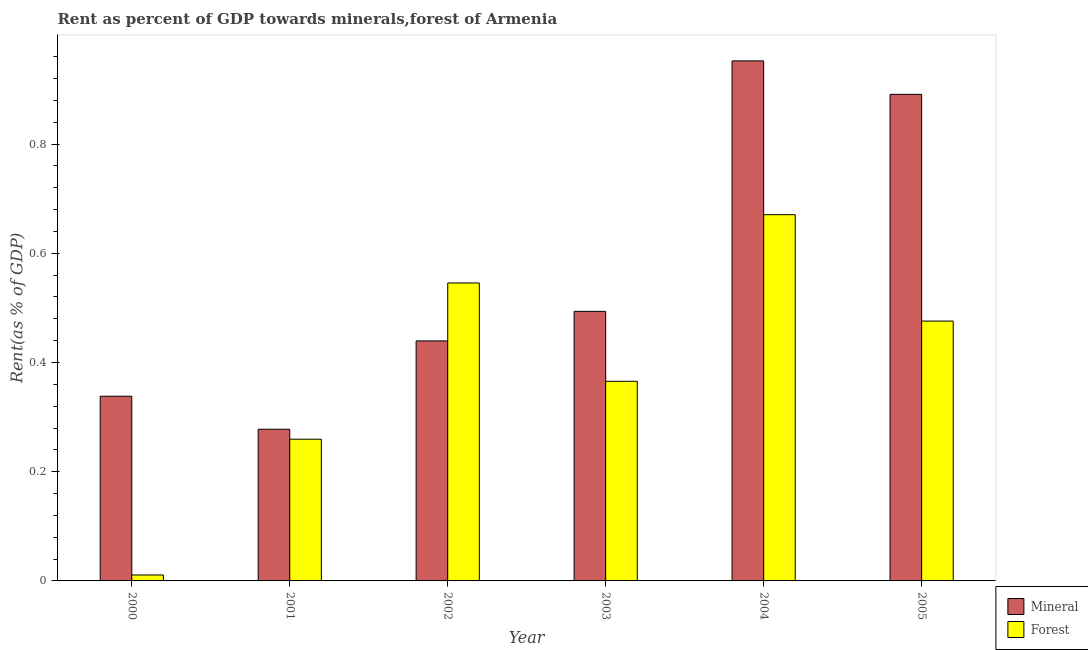How many different coloured bars are there?
Offer a terse response. 2. How many groups of bars are there?
Your response must be concise. 6. Are the number of bars per tick equal to the number of legend labels?
Offer a terse response. Yes. Are the number of bars on each tick of the X-axis equal?
Your answer should be compact. Yes. What is the label of the 6th group of bars from the left?
Your answer should be compact. 2005. In how many cases, is the number of bars for a given year not equal to the number of legend labels?
Your answer should be compact. 0. What is the forest rent in 2003?
Ensure brevity in your answer.  0.37. Across all years, what is the maximum mineral rent?
Keep it short and to the point. 0.95. Across all years, what is the minimum forest rent?
Offer a very short reply. 0.01. What is the total forest rent in the graph?
Keep it short and to the point. 2.33. What is the difference between the mineral rent in 2003 and that in 2004?
Give a very brief answer. -0.46. What is the difference between the mineral rent in 2004 and the forest rent in 2002?
Keep it short and to the point. 0.51. What is the average forest rent per year?
Your answer should be compact. 0.39. In the year 2003, what is the difference between the forest rent and mineral rent?
Provide a short and direct response. 0. In how many years, is the forest rent greater than 0.7200000000000001 %?
Give a very brief answer. 0. What is the ratio of the forest rent in 2000 to that in 2002?
Provide a short and direct response. 0.02. Is the mineral rent in 2000 less than that in 2004?
Give a very brief answer. Yes. Is the difference between the mineral rent in 2000 and 2002 greater than the difference between the forest rent in 2000 and 2002?
Your response must be concise. No. What is the difference between the highest and the second highest mineral rent?
Offer a terse response. 0.06. What is the difference between the highest and the lowest forest rent?
Provide a succinct answer. 0.66. In how many years, is the forest rent greater than the average forest rent taken over all years?
Provide a short and direct response. 3. What does the 2nd bar from the left in 2000 represents?
Keep it short and to the point. Forest. What does the 2nd bar from the right in 2000 represents?
Make the answer very short. Mineral. Are all the bars in the graph horizontal?
Your response must be concise. No. What is the difference between two consecutive major ticks on the Y-axis?
Give a very brief answer. 0.2. Does the graph contain grids?
Make the answer very short. No. Where does the legend appear in the graph?
Provide a short and direct response. Bottom right. How many legend labels are there?
Offer a very short reply. 2. How are the legend labels stacked?
Give a very brief answer. Vertical. What is the title of the graph?
Offer a very short reply. Rent as percent of GDP towards minerals,forest of Armenia. What is the label or title of the X-axis?
Offer a terse response. Year. What is the label or title of the Y-axis?
Your response must be concise. Rent(as % of GDP). What is the Rent(as % of GDP) of Mineral in 2000?
Give a very brief answer. 0.34. What is the Rent(as % of GDP) in Forest in 2000?
Your answer should be compact. 0.01. What is the Rent(as % of GDP) in Mineral in 2001?
Give a very brief answer. 0.28. What is the Rent(as % of GDP) of Forest in 2001?
Give a very brief answer. 0.26. What is the Rent(as % of GDP) in Mineral in 2002?
Offer a terse response. 0.44. What is the Rent(as % of GDP) of Forest in 2002?
Ensure brevity in your answer.  0.55. What is the Rent(as % of GDP) of Mineral in 2003?
Your response must be concise. 0.49. What is the Rent(as % of GDP) of Forest in 2003?
Provide a succinct answer. 0.37. What is the Rent(as % of GDP) in Mineral in 2004?
Provide a short and direct response. 0.95. What is the Rent(as % of GDP) in Forest in 2004?
Your answer should be very brief. 0.67. What is the Rent(as % of GDP) in Mineral in 2005?
Give a very brief answer. 0.89. What is the Rent(as % of GDP) in Forest in 2005?
Your answer should be very brief. 0.48. Across all years, what is the maximum Rent(as % of GDP) of Mineral?
Your answer should be very brief. 0.95. Across all years, what is the maximum Rent(as % of GDP) of Forest?
Your response must be concise. 0.67. Across all years, what is the minimum Rent(as % of GDP) of Mineral?
Ensure brevity in your answer.  0.28. Across all years, what is the minimum Rent(as % of GDP) of Forest?
Give a very brief answer. 0.01. What is the total Rent(as % of GDP) of Mineral in the graph?
Your response must be concise. 3.39. What is the total Rent(as % of GDP) of Forest in the graph?
Your response must be concise. 2.33. What is the difference between the Rent(as % of GDP) of Mineral in 2000 and that in 2001?
Make the answer very short. 0.06. What is the difference between the Rent(as % of GDP) in Forest in 2000 and that in 2001?
Your response must be concise. -0.25. What is the difference between the Rent(as % of GDP) in Mineral in 2000 and that in 2002?
Provide a short and direct response. -0.1. What is the difference between the Rent(as % of GDP) in Forest in 2000 and that in 2002?
Your response must be concise. -0.53. What is the difference between the Rent(as % of GDP) in Mineral in 2000 and that in 2003?
Provide a short and direct response. -0.16. What is the difference between the Rent(as % of GDP) in Forest in 2000 and that in 2003?
Your answer should be compact. -0.35. What is the difference between the Rent(as % of GDP) of Mineral in 2000 and that in 2004?
Make the answer very short. -0.61. What is the difference between the Rent(as % of GDP) of Forest in 2000 and that in 2004?
Provide a succinct answer. -0.66. What is the difference between the Rent(as % of GDP) in Mineral in 2000 and that in 2005?
Offer a terse response. -0.55. What is the difference between the Rent(as % of GDP) of Forest in 2000 and that in 2005?
Your answer should be very brief. -0.47. What is the difference between the Rent(as % of GDP) of Mineral in 2001 and that in 2002?
Offer a terse response. -0.16. What is the difference between the Rent(as % of GDP) in Forest in 2001 and that in 2002?
Offer a terse response. -0.29. What is the difference between the Rent(as % of GDP) of Mineral in 2001 and that in 2003?
Provide a succinct answer. -0.22. What is the difference between the Rent(as % of GDP) in Forest in 2001 and that in 2003?
Provide a short and direct response. -0.11. What is the difference between the Rent(as % of GDP) in Mineral in 2001 and that in 2004?
Your answer should be very brief. -0.67. What is the difference between the Rent(as % of GDP) in Forest in 2001 and that in 2004?
Your answer should be very brief. -0.41. What is the difference between the Rent(as % of GDP) of Mineral in 2001 and that in 2005?
Your answer should be very brief. -0.61. What is the difference between the Rent(as % of GDP) in Forest in 2001 and that in 2005?
Your response must be concise. -0.22. What is the difference between the Rent(as % of GDP) of Mineral in 2002 and that in 2003?
Provide a succinct answer. -0.05. What is the difference between the Rent(as % of GDP) in Forest in 2002 and that in 2003?
Your response must be concise. 0.18. What is the difference between the Rent(as % of GDP) in Mineral in 2002 and that in 2004?
Ensure brevity in your answer.  -0.51. What is the difference between the Rent(as % of GDP) of Forest in 2002 and that in 2004?
Keep it short and to the point. -0.12. What is the difference between the Rent(as % of GDP) of Mineral in 2002 and that in 2005?
Give a very brief answer. -0.45. What is the difference between the Rent(as % of GDP) of Forest in 2002 and that in 2005?
Give a very brief answer. 0.07. What is the difference between the Rent(as % of GDP) in Mineral in 2003 and that in 2004?
Your answer should be compact. -0.46. What is the difference between the Rent(as % of GDP) in Forest in 2003 and that in 2004?
Give a very brief answer. -0.31. What is the difference between the Rent(as % of GDP) in Mineral in 2003 and that in 2005?
Ensure brevity in your answer.  -0.4. What is the difference between the Rent(as % of GDP) in Forest in 2003 and that in 2005?
Keep it short and to the point. -0.11. What is the difference between the Rent(as % of GDP) in Mineral in 2004 and that in 2005?
Provide a short and direct response. 0.06. What is the difference between the Rent(as % of GDP) of Forest in 2004 and that in 2005?
Ensure brevity in your answer.  0.19. What is the difference between the Rent(as % of GDP) in Mineral in 2000 and the Rent(as % of GDP) in Forest in 2001?
Offer a terse response. 0.08. What is the difference between the Rent(as % of GDP) of Mineral in 2000 and the Rent(as % of GDP) of Forest in 2002?
Ensure brevity in your answer.  -0.21. What is the difference between the Rent(as % of GDP) of Mineral in 2000 and the Rent(as % of GDP) of Forest in 2003?
Ensure brevity in your answer.  -0.03. What is the difference between the Rent(as % of GDP) of Mineral in 2000 and the Rent(as % of GDP) of Forest in 2004?
Provide a succinct answer. -0.33. What is the difference between the Rent(as % of GDP) of Mineral in 2000 and the Rent(as % of GDP) of Forest in 2005?
Keep it short and to the point. -0.14. What is the difference between the Rent(as % of GDP) in Mineral in 2001 and the Rent(as % of GDP) in Forest in 2002?
Your answer should be very brief. -0.27. What is the difference between the Rent(as % of GDP) in Mineral in 2001 and the Rent(as % of GDP) in Forest in 2003?
Make the answer very short. -0.09. What is the difference between the Rent(as % of GDP) of Mineral in 2001 and the Rent(as % of GDP) of Forest in 2004?
Keep it short and to the point. -0.39. What is the difference between the Rent(as % of GDP) of Mineral in 2001 and the Rent(as % of GDP) of Forest in 2005?
Give a very brief answer. -0.2. What is the difference between the Rent(as % of GDP) in Mineral in 2002 and the Rent(as % of GDP) in Forest in 2003?
Provide a short and direct response. 0.07. What is the difference between the Rent(as % of GDP) of Mineral in 2002 and the Rent(as % of GDP) of Forest in 2004?
Give a very brief answer. -0.23. What is the difference between the Rent(as % of GDP) in Mineral in 2002 and the Rent(as % of GDP) in Forest in 2005?
Ensure brevity in your answer.  -0.04. What is the difference between the Rent(as % of GDP) in Mineral in 2003 and the Rent(as % of GDP) in Forest in 2004?
Your response must be concise. -0.18. What is the difference between the Rent(as % of GDP) in Mineral in 2003 and the Rent(as % of GDP) in Forest in 2005?
Make the answer very short. 0.02. What is the difference between the Rent(as % of GDP) in Mineral in 2004 and the Rent(as % of GDP) in Forest in 2005?
Ensure brevity in your answer.  0.48. What is the average Rent(as % of GDP) in Mineral per year?
Ensure brevity in your answer.  0.57. What is the average Rent(as % of GDP) in Forest per year?
Offer a very short reply. 0.39. In the year 2000, what is the difference between the Rent(as % of GDP) in Mineral and Rent(as % of GDP) in Forest?
Ensure brevity in your answer.  0.33. In the year 2001, what is the difference between the Rent(as % of GDP) of Mineral and Rent(as % of GDP) of Forest?
Offer a very short reply. 0.02. In the year 2002, what is the difference between the Rent(as % of GDP) in Mineral and Rent(as % of GDP) in Forest?
Keep it short and to the point. -0.11. In the year 2003, what is the difference between the Rent(as % of GDP) in Mineral and Rent(as % of GDP) in Forest?
Provide a short and direct response. 0.13. In the year 2004, what is the difference between the Rent(as % of GDP) of Mineral and Rent(as % of GDP) of Forest?
Provide a short and direct response. 0.28. In the year 2005, what is the difference between the Rent(as % of GDP) of Mineral and Rent(as % of GDP) of Forest?
Provide a short and direct response. 0.42. What is the ratio of the Rent(as % of GDP) of Mineral in 2000 to that in 2001?
Offer a terse response. 1.22. What is the ratio of the Rent(as % of GDP) in Forest in 2000 to that in 2001?
Keep it short and to the point. 0.04. What is the ratio of the Rent(as % of GDP) in Mineral in 2000 to that in 2002?
Provide a succinct answer. 0.77. What is the ratio of the Rent(as % of GDP) of Forest in 2000 to that in 2002?
Provide a succinct answer. 0.02. What is the ratio of the Rent(as % of GDP) of Mineral in 2000 to that in 2003?
Offer a terse response. 0.69. What is the ratio of the Rent(as % of GDP) of Forest in 2000 to that in 2003?
Ensure brevity in your answer.  0.03. What is the ratio of the Rent(as % of GDP) in Mineral in 2000 to that in 2004?
Offer a terse response. 0.36. What is the ratio of the Rent(as % of GDP) in Forest in 2000 to that in 2004?
Provide a succinct answer. 0.02. What is the ratio of the Rent(as % of GDP) of Mineral in 2000 to that in 2005?
Keep it short and to the point. 0.38. What is the ratio of the Rent(as % of GDP) in Forest in 2000 to that in 2005?
Make the answer very short. 0.02. What is the ratio of the Rent(as % of GDP) in Mineral in 2001 to that in 2002?
Make the answer very short. 0.63. What is the ratio of the Rent(as % of GDP) in Forest in 2001 to that in 2002?
Your answer should be compact. 0.48. What is the ratio of the Rent(as % of GDP) of Mineral in 2001 to that in 2003?
Give a very brief answer. 0.56. What is the ratio of the Rent(as % of GDP) in Forest in 2001 to that in 2003?
Offer a terse response. 0.71. What is the ratio of the Rent(as % of GDP) of Mineral in 2001 to that in 2004?
Offer a very short reply. 0.29. What is the ratio of the Rent(as % of GDP) of Forest in 2001 to that in 2004?
Your answer should be compact. 0.39. What is the ratio of the Rent(as % of GDP) in Mineral in 2001 to that in 2005?
Give a very brief answer. 0.31. What is the ratio of the Rent(as % of GDP) in Forest in 2001 to that in 2005?
Ensure brevity in your answer.  0.55. What is the ratio of the Rent(as % of GDP) of Mineral in 2002 to that in 2003?
Give a very brief answer. 0.89. What is the ratio of the Rent(as % of GDP) in Forest in 2002 to that in 2003?
Your answer should be very brief. 1.49. What is the ratio of the Rent(as % of GDP) in Mineral in 2002 to that in 2004?
Your response must be concise. 0.46. What is the ratio of the Rent(as % of GDP) in Forest in 2002 to that in 2004?
Your answer should be very brief. 0.81. What is the ratio of the Rent(as % of GDP) of Mineral in 2002 to that in 2005?
Your response must be concise. 0.49. What is the ratio of the Rent(as % of GDP) in Forest in 2002 to that in 2005?
Keep it short and to the point. 1.15. What is the ratio of the Rent(as % of GDP) in Mineral in 2003 to that in 2004?
Offer a terse response. 0.52. What is the ratio of the Rent(as % of GDP) of Forest in 2003 to that in 2004?
Your answer should be very brief. 0.55. What is the ratio of the Rent(as % of GDP) in Mineral in 2003 to that in 2005?
Offer a terse response. 0.55. What is the ratio of the Rent(as % of GDP) in Forest in 2003 to that in 2005?
Your answer should be compact. 0.77. What is the ratio of the Rent(as % of GDP) in Mineral in 2004 to that in 2005?
Your response must be concise. 1.07. What is the ratio of the Rent(as % of GDP) of Forest in 2004 to that in 2005?
Provide a succinct answer. 1.41. What is the difference between the highest and the second highest Rent(as % of GDP) of Mineral?
Make the answer very short. 0.06. What is the difference between the highest and the second highest Rent(as % of GDP) in Forest?
Offer a very short reply. 0.12. What is the difference between the highest and the lowest Rent(as % of GDP) of Mineral?
Your response must be concise. 0.67. What is the difference between the highest and the lowest Rent(as % of GDP) of Forest?
Provide a succinct answer. 0.66. 